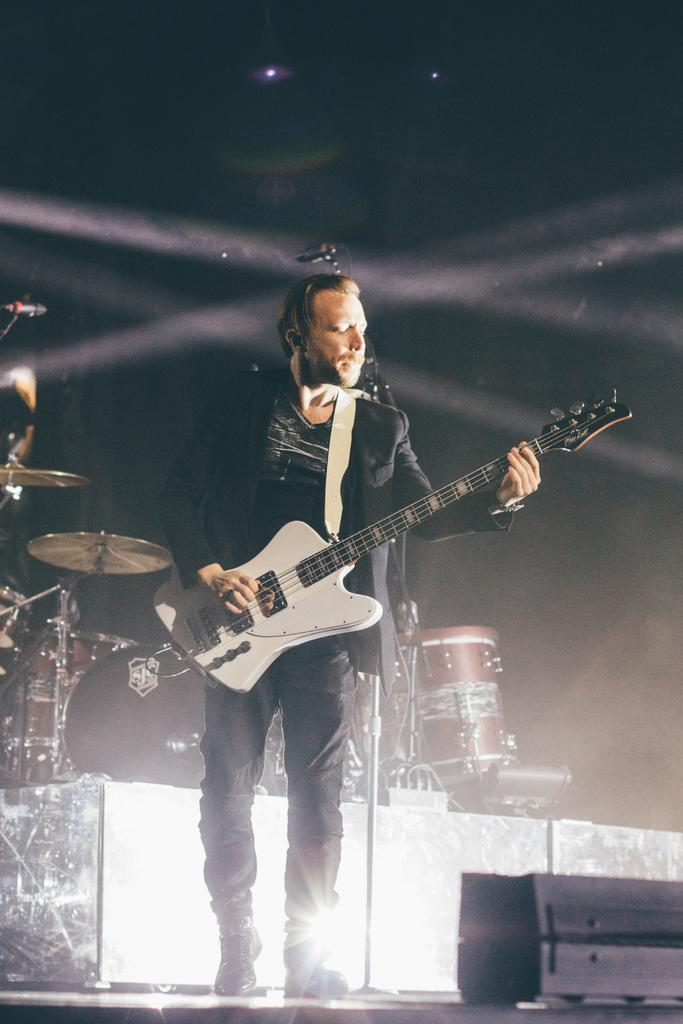Who is present in the image? There is a person in the image. What is the person wearing? The person is wearing a black dress. What is the person doing in the image? The person is playing a guitar. What other musical instruments can be seen in the background of the image? There are drums and microphones in the background of the image. What type of food is being prepared on the guitar in the image? There is no food present in the image, and the guitar is not being used for cooking or food preparation. 